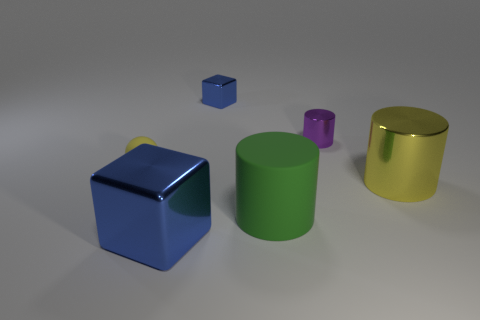Subtract all big cylinders. How many cylinders are left? 1 Add 2 yellow objects. How many objects exist? 8 Subtract 1 cylinders. How many cylinders are left? 2 Subtract all cyan balls. Subtract all yellow cylinders. How many balls are left? 1 Subtract all green balls. How many yellow cylinders are left? 1 Subtract all large purple rubber cylinders. Subtract all large blue shiny things. How many objects are left? 5 Add 5 spheres. How many spheres are left? 6 Add 3 tiny purple metallic things. How many tiny purple metallic things exist? 4 Subtract 1 yellow spheres. How many objects are left? 5 Subtract all balls. How many objects are left? 5 